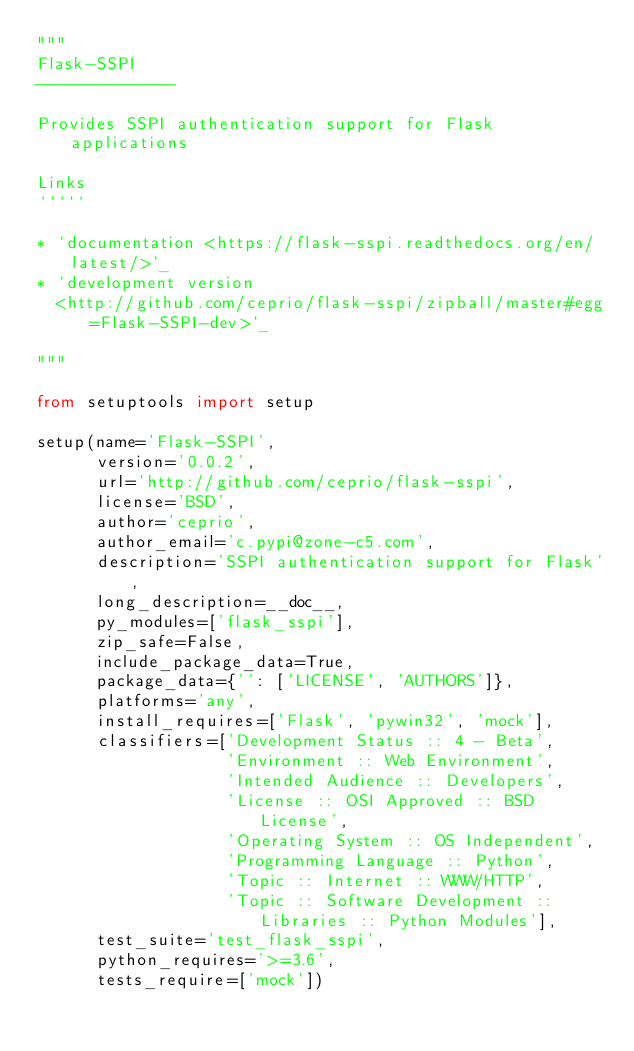Convert code to text. <code><loc_0><loc_0><loc_500><loc_500><_Python_>"""
Flask-SSPI
--------------

Provides SSPI authentication support for Flask applications

Links
`````

* `documentation <https://flask-sspi.readthedocs.org/en/latest/>`_
* `development version
  <http://github.com/ceprio/flask-sspi/zipball/master#egg=Flask-SSPI-dev>`_

"""

from setuptools import setup

setup(name='Flask-SSPI',
      version='0.0.2',
      url='http://github.com/ceprio/flask-sspi',
      license='BSD',
      author='ceprio',
      author_email='c.pypi@zone-c5.com',
      description='SSPI authentication support for Flask',
      long_description=__doc__,
      py_modules=['flask_sspi'],
      zip_safe=False,
      include_package_data=True,
      package_data={'': ['LICENSE', 'AUTHORS']},
      platforms='any',
      install_requires=['Flask', 'pywin32', 'mock'],
      classifiers=['Development Status :: 4 - Beta',
                   'Environment :: Web Environment',
                   'Intended Audience :: Developers',
                   'License :: OSI Approved :: BSD License',
                   'Operating System :: OS Independent',
                   'Programming Language :: Python',
                   'Topic :: Internet :: WWW/HTTP',
                   'Topic :: Software Development :: Libraries :: Python Modules'],
      test_suite='test_flask_sspi',
      python_requires='>=3.6',
      tests_require=['mock'])
</code> 